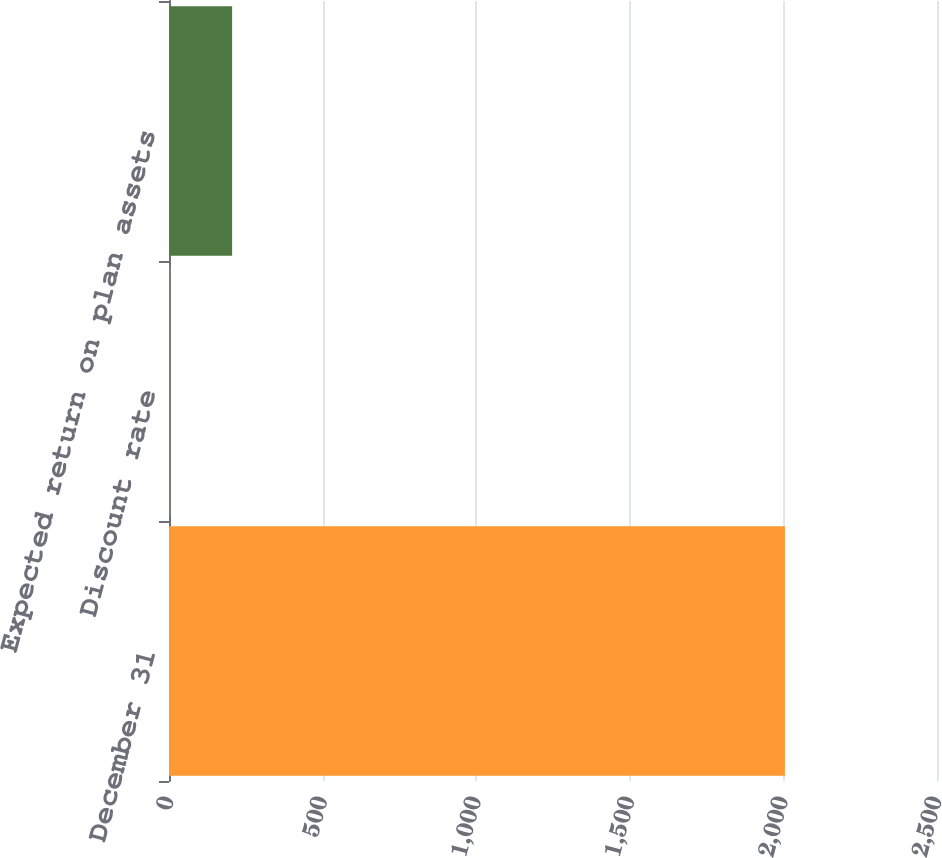Convert chart. <chart><loc_0><loc_0><loc_500><loc_500><bar_chart><fcel>December 31<fcel>Discount rate<fcel>Expected return on plan assets<nl><fcel>2005<fcel>5.5<fcel>205.45<nl></chart> 